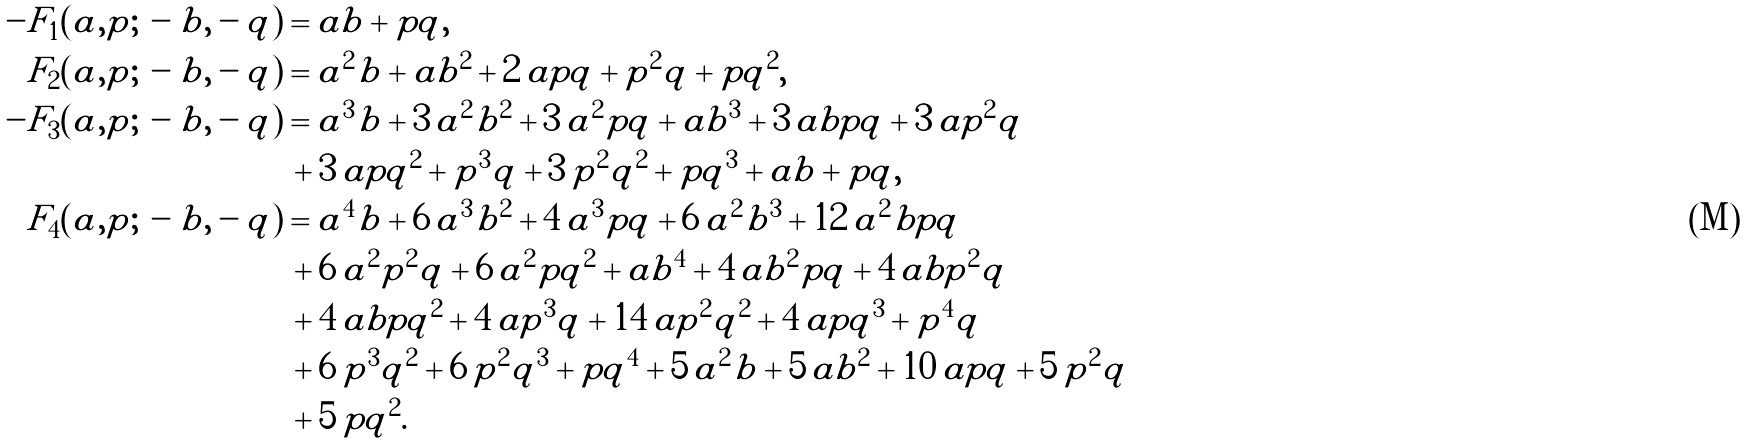Convert formula to latex. <formula><loc_0><loc_0><loc_500><loc_500>- F _ { 1 } ( a , p ; \, - b , - q ) & = a b + p q , \\ F _ { 2 } ( a , p ; \, - b , - q ) & = { a } ^ { 2 } b + a { b } ^ { 2 } + 2 \, a p q + { p } ^ { 2 } q + p { q } ^ { 2 } , \\ - F _ { 3 } ( a , p ; \, - b , - q ) & = { a } ^ { 3 } b + 3 \, { a } ^ { 2 } { b } ^ { 2 } + 3 \, { a } ^ { 2 } p q + a { b } ^ { 3 } + 3 \, a b p q + 3 \, a { p } ^ { 2 } q \\ & \, + 3 \, a p { q } ^ { 2 } + { p } ^ { 3 } q + 3 \, { p } ^ { 2 } { q } ^ { 2 } + p { q } ^ { 3 } + a b + p q , \\ F _ { 4 } ( a , p ; \, - b , - q ) & = { a } ^ { 4 } b + 6 \, { a } ^ { 3 } { b } ^ { 2 } + 4 \, { a } ^ { 3 } p q + 6 \, { a } ^ { 2 } { b } ^ { 3 } + 1 2 \, { a } ^ { 2 } b p q \\ & \, + 6 \, { a } ^ { 2 } { p } ^ { 2 } q + 6 \, { a } ^ { 2 } p { q } ^ { 2 } + a { b } ^ { 4 } + 4 \, a { b } ^ { 2 } p q + 4 \, a b { p } ^ { 2 } q \\ & \, + 4 \, a b p { q } ^ { 2 } + 4 \, a { p } ^ { 3 } q + 1 4 \, a { p } ^ { 2 } { q } ^ { 2 } + 4 \, a p { q } ^ { 3 } + { p } ^ { 4 } q \\ & \, + 6 \, { p } ^ { 3 } { q } ^ { 2 } + 6 \, { p } ^ { 2 } { q } ^ { 3 } + p { q } ^ { 4 } + 5 \, { a } ^ { 2 } b + 5 \, a { b } ^ { 2 } + 1 0 \, a p q + 5 \, { p } ^ { 2 } q \\ & \, + 5 \, p { q } ^ { 2 } .</formula> 